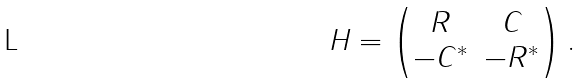<formula> <loc_0><loc_0><loc_500><loc_500>H = \begin{pmatrix} R & C \\ - C ^ { * } & - R ^ { * } \end{pmatrix} .</formula> 